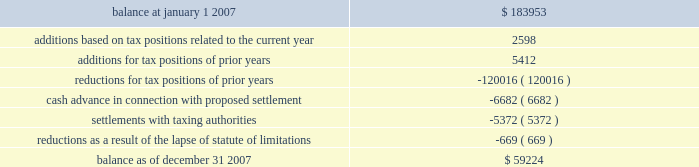American tower corporation and subsidiaries notes to consolidated financial statements 2014 ( continued ) company is currently unable to estimate the impact of the amount of such changes , if any , to previously recorded uncertain tax positions .
A reconciliation of the beginning and ending amount of unrecognized tax benefits for the year ending december 31 , 2007 is as follows ( in thousands ) : .
During the year ended december 31 , 2007 , the company recorded penalties and tax-related interest income of $ 2.5 million and interest income from tax refunds of $ 1.5 million for the year ended december 31 , 2007 .
As of december 31 , 2007 and january 1 , 2007 , the total unrecognized tax benefits included in other long-term liabilities in the consolidated balance sheets was $ 29.6 million and $ 34.3 million , respectively .
As of december 31 , 2007 and january 1 , 2007 , the total amount of accrued income tax-related interest and penalties included in other long-term liabilities in the consolidated balance sheets was $ 30.7 million and $ 33.2 million , respectively .
In the fourth quarter of 2007 , the company entered into a tax amnesty program with the mexican tax authority .
As of december 31 , 2007 , the company had met all of the administrative requirements of the program , which enabled the company to recognize certain tax benefits .
This was confirmed by the mexican tax authority on february 5 , 2008 .
These benefits include a reduction of uncertain tax benefits of $ 5.4 million along with penalties and interest of $ 12.5 million related to 2002 , all of which reduced income tax expense .
In connection with the above program , the company paid $ 6.7 million to the mexican tax authority as a settlement offer for other uncertain tax positions related to 2003 and 2004 .
This offer is currently under review by the mexican tax authority ; the company cannot yet determine the specific timing or the amount of any potential settlement .
During 2007 , the statute of limitations on certain unrecognized tax benefits lapsed , which resulted in a $ 0.7 million decrease in the liability for uncertain tax benefits , all of which reduced the income tax provision .
The company files numerous consolidated and separate income tax returns , including u.s .
Federal and state tax returns and foreign tax returns in mexico and brazil .
As a result of the company 2019s ability to carry forward federal and state net operating losses , the applicable tax years remain open to examination until three years after the applicable loss carryforwards have been used or expired .
However , the company has completed u.s .
Federal income tax examinations for tax years up to and including 2002 .
The company is currently undergoing u.s .
Federal income tax examinations for tax years 2004 and 2005 .
Additionally , it is subject to examinations in various u.s .
State jurisdictions for certain tax years , and is under examination in brazil for the 2001 through 2006 tax years and mexico for the 2002 tax year .
Sfas no .
109 , 201caccounting for income taxes , 201d requires that companies record a valuation allowance when it is 201cmore likely than not that some portion or all of the deferred tax assets will not be realized . 201d at december 31 , 2007 , the company has provided a valuation allowance of approximately $ 88.2 million , including approximately .
As of december 31 , 2007 , interest and penalties were what percent of the total unrecognized tax benefits included in other long-term liabilities? 
Computations: (30.7 / 29.6)
Answer: 1.03716. 